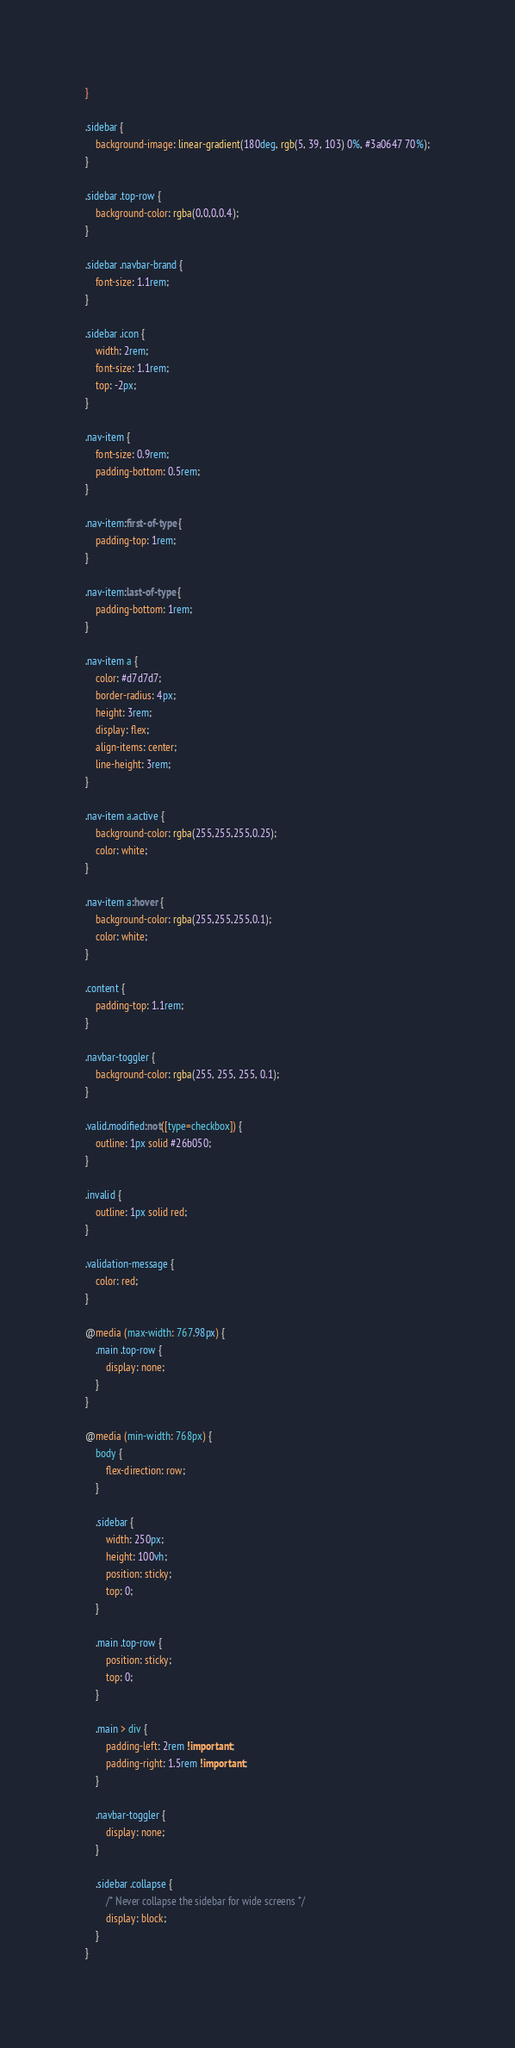<code> <loc_0><loc_0><loc_500><loc_500><_CSS_>}

.sidebar {
    background-image: linear-gradient(180deg, rgb(5, 39, 103) 0%, #3a0647 70%);
}

.sidebar .top-row {
    background-color: rgba(0,0,0,0.4);
}

.sidebar .navbar-brand {
    font-size: 1.1rem;
}

.sidebar .icon {
    width: 2rem;
    font-size: 1.1rem;
    top: -2px;
}

.nav-item {
    font-size: 0.9rem;
    padding-bottom: 0.5rem;
}

.nav-item:first-of-type {
    padding-top: 1rem;
}

.nav-item:last-of-type {
    padding-bottom: 1rem;
}

.nav-item a {
    color: #d7d7d7;
    border-radius: 4px;
    height: 3rem;
    display: flex;
    align-items: center;
    line-height: 3rem;
}

.nav-item a.active {
    background-color: rgba(255,255,255,0.25);
    color: white;
}

.nav-item a:hover {
    background-color: rgba(255,255,255,0.1);
    color: white;
}

.content {
    padding-top: 1.1rem;
}

.navbar-toggler {
    background-color: rgba(255, 255, 255, 0.1);
}

.valid.modified:not([type=checkbox]) {
    outline: 1px solid #26b050;
}

.invalid {
    outline: 1px solid red;
}

.validation-message {
    color: red;
}

@media (max-width: 767.98px) {
    .main .top-row {
        display: none;
    }
}

@media (min-width: 768px) {
    body {
        flex-direction: row;
    }

    .sidebar {
        width: 250px;
        height: 100vh;
        position: sticky;
        top: 0;
    }

    .main .top-row {
        position: sticky;
        top: 0;
    }

    .main > div {
        padding-left: 2rem !important;
        padding-right: 1.5rem !important;
    }

    .navbar-toggler {
        display: none;
    }

    .sidebar .collapse {
        /* Never collapse the sidebar for wide screens */
        display: block;
    }
}
</code> 